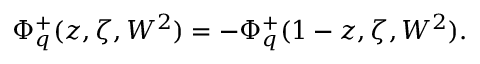Convert formula to latex. <formula><loc_0><loc_0><loc_500><loc_500>\Phi _ { q } ^ { + } ( z , \zeta , W ^ { 2 } ) = - \Phi _ { q } ^ { + } ( 1 - z , \zeta , W ^ { 2 } ) .</formula> 